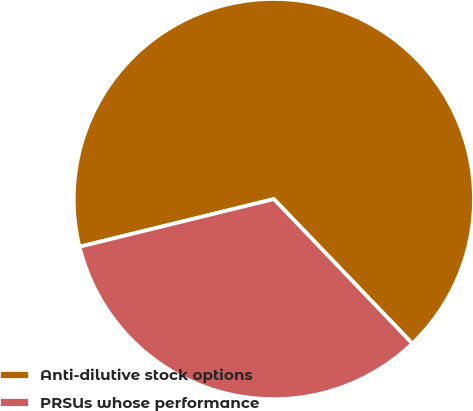Convert chart. <chart><loc_0><loc_0><loc_500><loc_500><pie_chart><fcel>Anti-dilutive stock options<fcel>PRSUs whose performance<nl><fcel>66.67%<fcel>33.33%<nl></chart> 